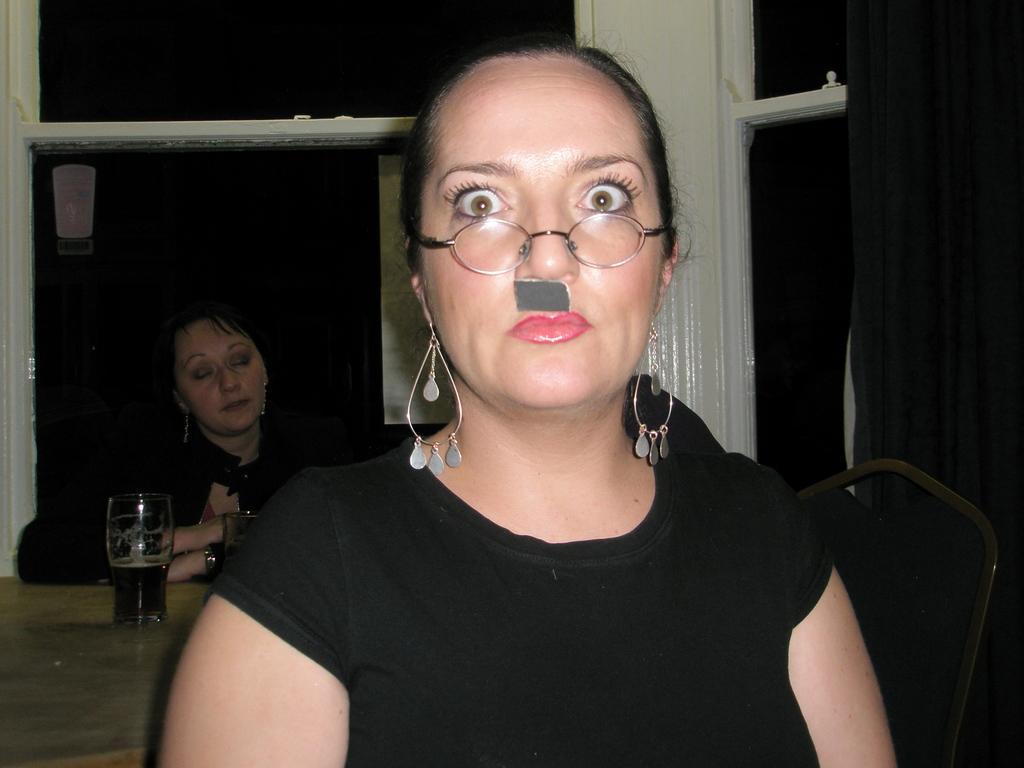How would you summarize this image in a sentence or two? This picture describes about few people, in the middle of the image we can see a woman, she wore spectacles, behind to her we can find glasses on the table, and we can see dark background. 